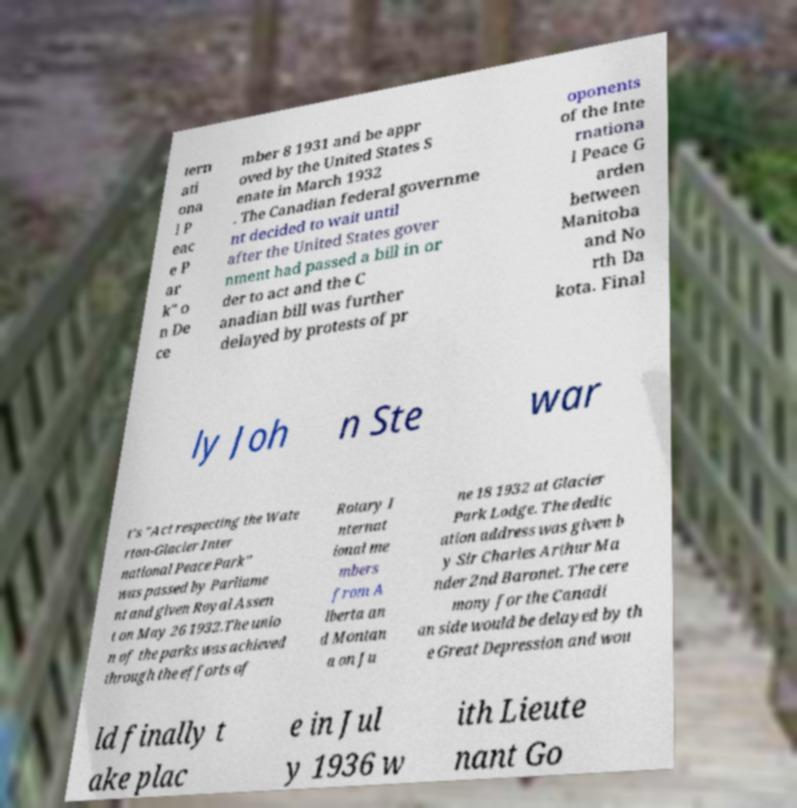I need the written content from this picture converted into text. Can you do that? tern ati ona l P eac e P ar k" o n De ce mber 8 1931 and be appr oved by the United States S enate in March 1932 . The Canadian federal governme nt decided to wait until after the United States gover nment had passed a bill in or der to act and the C anadian bill was further delayed by protests of pr oponents of the Inte rnationa l Peace G arden between Manitoba and No rth Da kota. Final ly Joh n Ste war t's "Act respecting the Wate rton-Glacier Inter national Peace Park" was passed by Parliame nt and given Royal Assen t on May 26 1932.The unio n of the parks was achieved through the efforts of Rotary I nternat ional me mbers from A lberta an d Montan a on Ju ne 18 1932 at Glacier Park Lodge. The dedic ation address was given b y Sir Charles Arthur Ma nder 2nd Baronet. The cere mony for the Canadi an side would be delayed by th e Great Depression and wou ld finally t ake plac e in Jul y 1936 w ith Lieute nant Go 